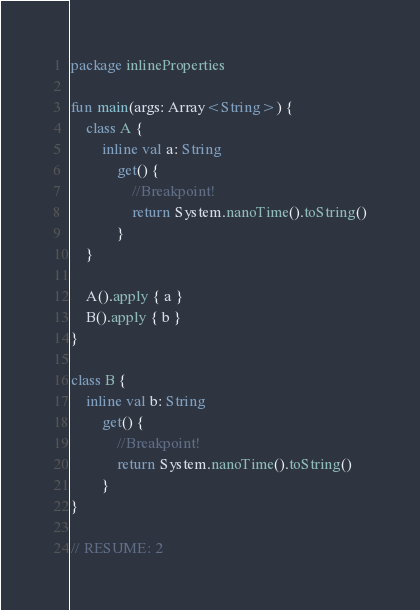Convert code to text. <code><loc_0><loc_0><loc_500><loc_500><_Kotlin_>package inlineProperties

fun main(args: Array<String>) {
    class A {
        inline val a: String
            get() {
                //Breakpoint!
                return System.nanoTime().toString()
            }
    }

    A().apply { a }
    B().apply { b }
}

class B {
    inline val b: String
        get() {
            //Breakpoint!
            return System.nanoTime().toString()
        }
}

// RESUME: 2</code> 